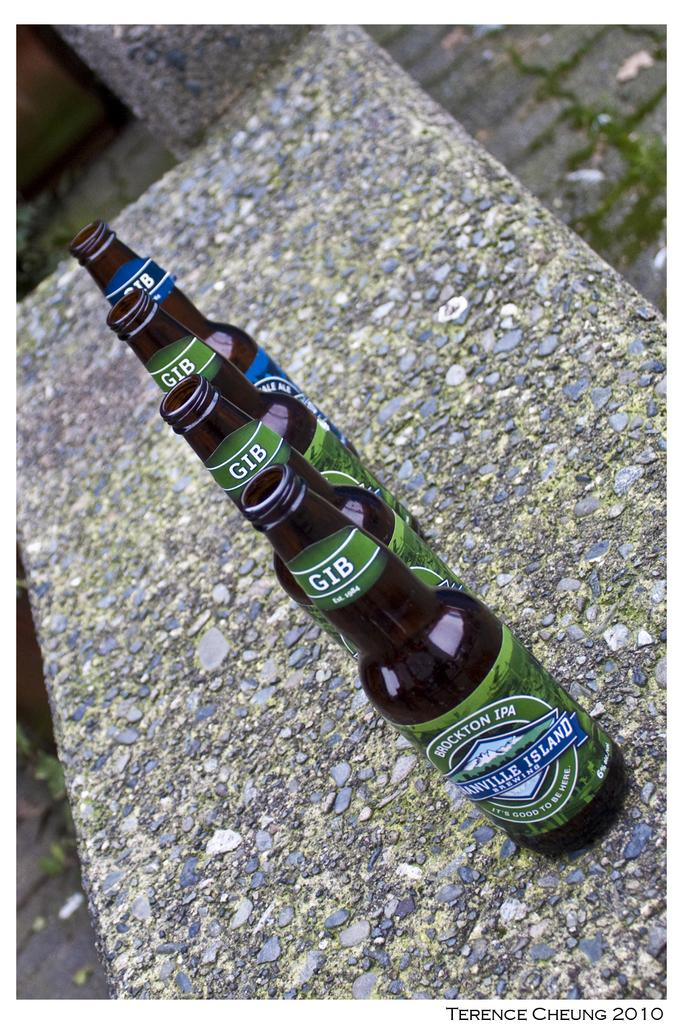<image>
Summarize the visual content of the image. Four bottles of beer from a company established in 1984 are lined up outdoors. 